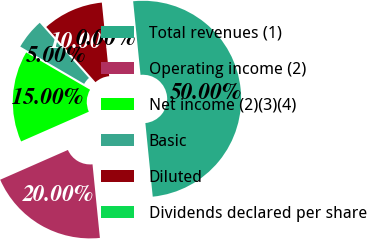Convert chart. <chart><loc_0><loc_0><loc_500><loc_500><pie_chart><fcel>Total revenues (1)<fcel>Operating income (2)<fcel>Net income (2)(3)(4)<fcel>Basic<fcel>Diluted<fcel>Dividends declared per share<nl><fcel>50.0%<fcel>20.0%<fcel>15.0%<fcel>5.0%<fcel>10.0%<fcel>0.0%<nl></chart> 